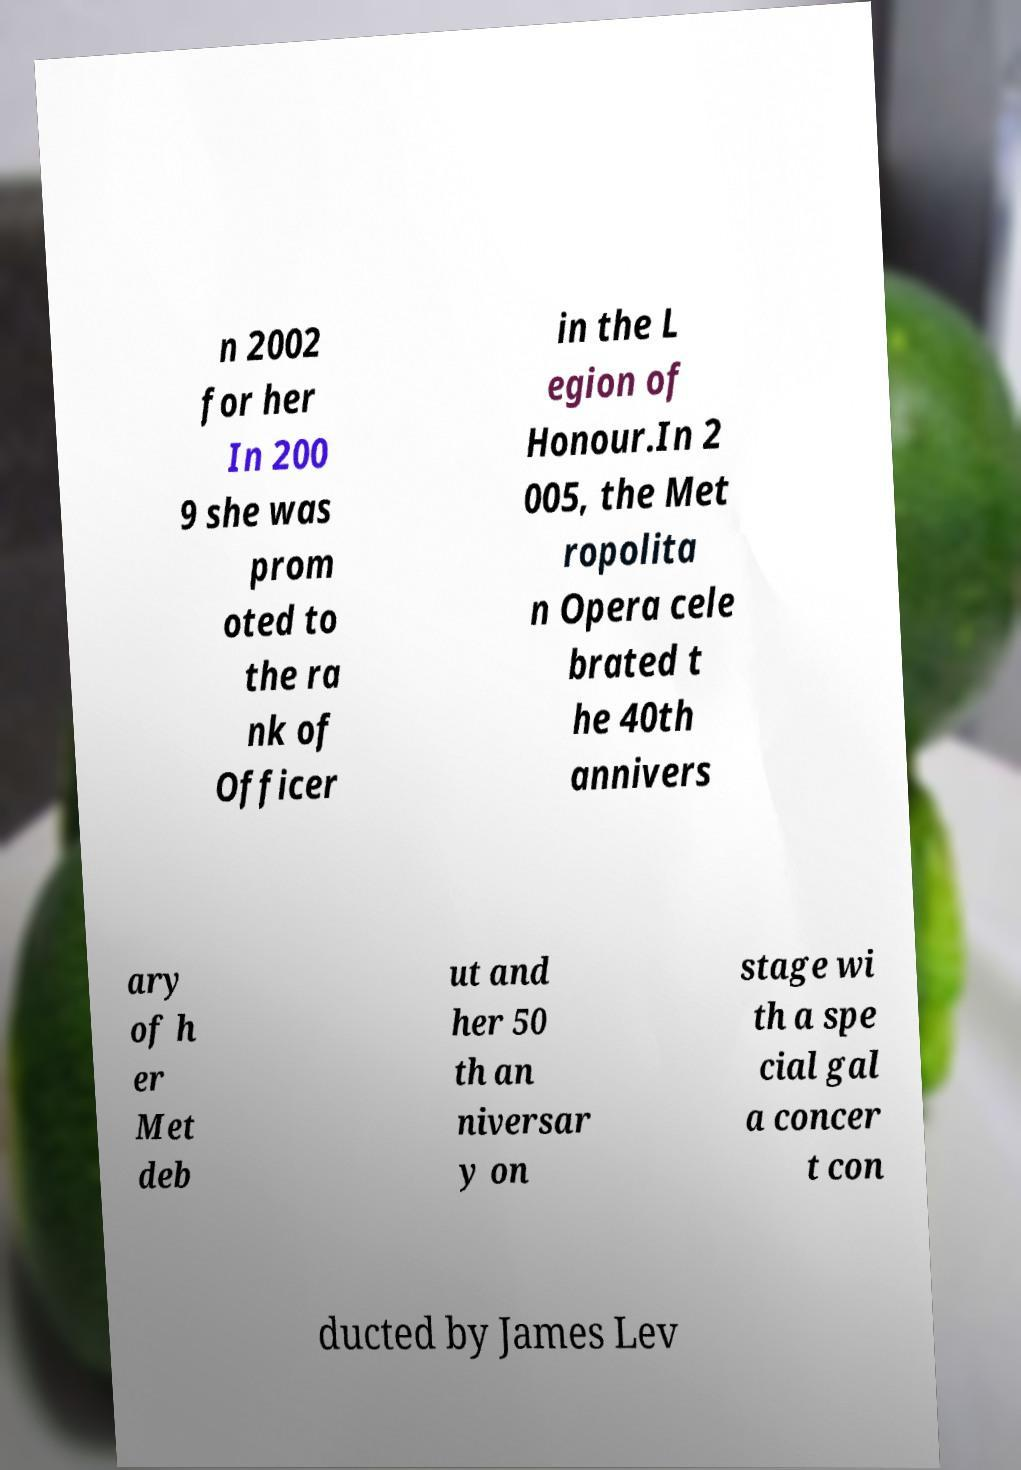Could you assist in decoding the text presented in this image and type it out clearly? n 2002 for her In 200 9 she was prom oted to the ra nk of Officer in the L egion of Honour.In 2 005, the Met ropolita n Opera cele brated t he 40th annivers ary of h er Met deb ut and her 50 th an niversar y on stage wi th a spe cial gal a concer t con ducted by James Lev 